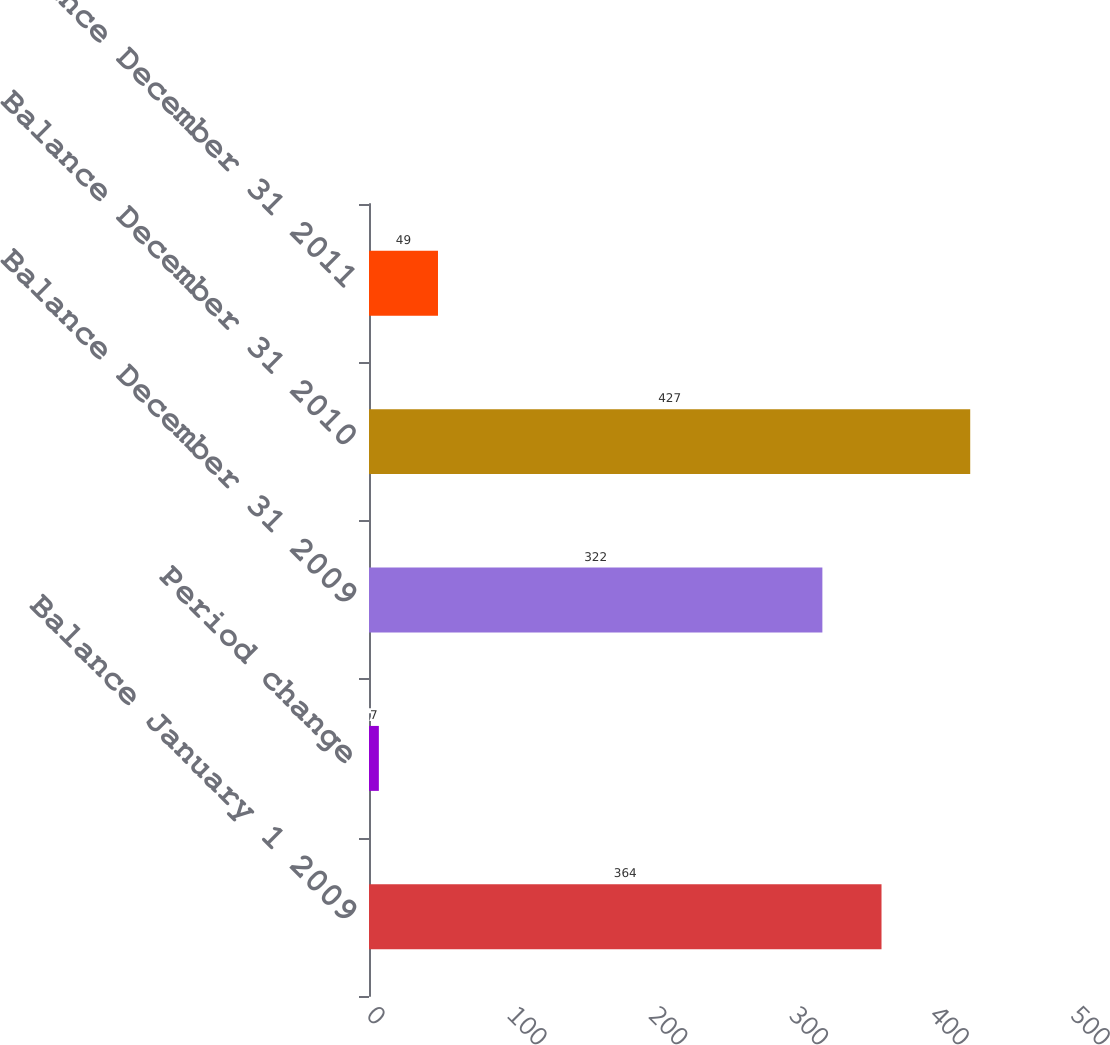Convert chart. <chart><loc_0><loc_0><loc_500><loc_500><bar_chart><fcel>Balance January 1 2009<fcel>Period change<fcel>Balance December 31 2009<fcel>Balance December 31 2010<fcel>Balance December 31 2011<nl><fcel>364<fcel>7<fcel>322<fcel>427<fcel>49<nl></chart> 